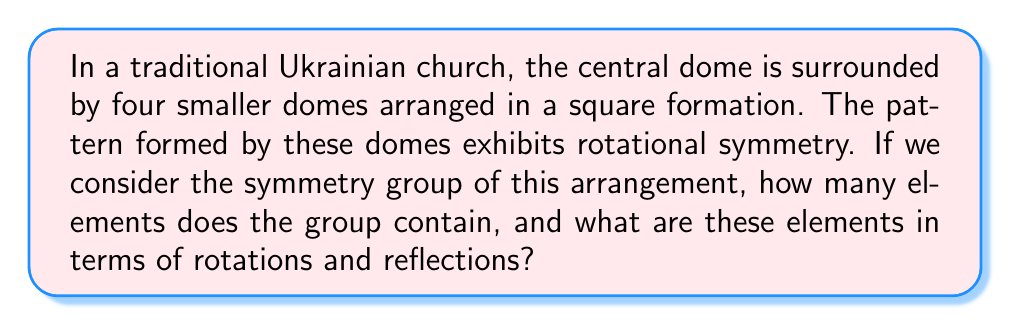Help me with this question. Let's approach this step-by-step using group theory:

1) First, we need to identify the symmetries of the dome arrangement. The pattern has:
   - Rotational symmetry of order 4 (90° rotations)
   - 4 lines of reflection symmetry (2 diagonal, 2 through the midpoints of opposite sides)

2) The symmetry group of this arrangement is known as the dihedral group $D_4$.

3) To find the elements of $D_4$, let's list them:
   - Identity transformation (e)
   - Rotations: 90° ($r$), 180° ($r^2$), 270° ($r^3$)
   - Reflections: 
     - Vertical ($v$)
     - Horizontal ($h$)
     - Two diagonal reflections ($d_1$ and $d_2$)

4) In total, we have:
   - 1 identity element
   - 3 rotations
   - 4 reflections

5) The order of the group is the total number of these elements:

   $|D_4| = 1 + 3 + 4 = 8$

6) We can represent these elements in cycle notation:
   - $e = (1)(2)(3)(4)$
   - $r = (1234)$
   - $r^2 = (13)(24)$
   - $r^3 = (1432)$
   - $v = (12)(34)$
   - $h = (14)(23)$
   - $d_1 = (1)(3)(24)$
   - $d_2 = (2)(4)(13)$

This group structure captures the symmetry of the traditional Ukrainian church dome arrangement, reflecting the architectural patterns in Ukrainian culture.
Answer: The symmetry group of the dome arrangement contains 8 elements: the identity transformation, 3 rotations (90°, 180°, 270°), and 4 reflections (vertical, horizontal, and two diagonal). 